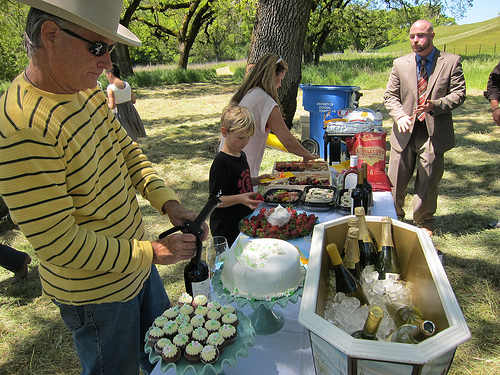<image>
Is there a woman behind the boy? Yes. From this viewpoint, the woman is positioned behind the boy, with the boy partially or fully occluding the woman. Is there a boy next to the tree? No. The boy is not positioned next to the tree. They are located in different areas of the scene. 